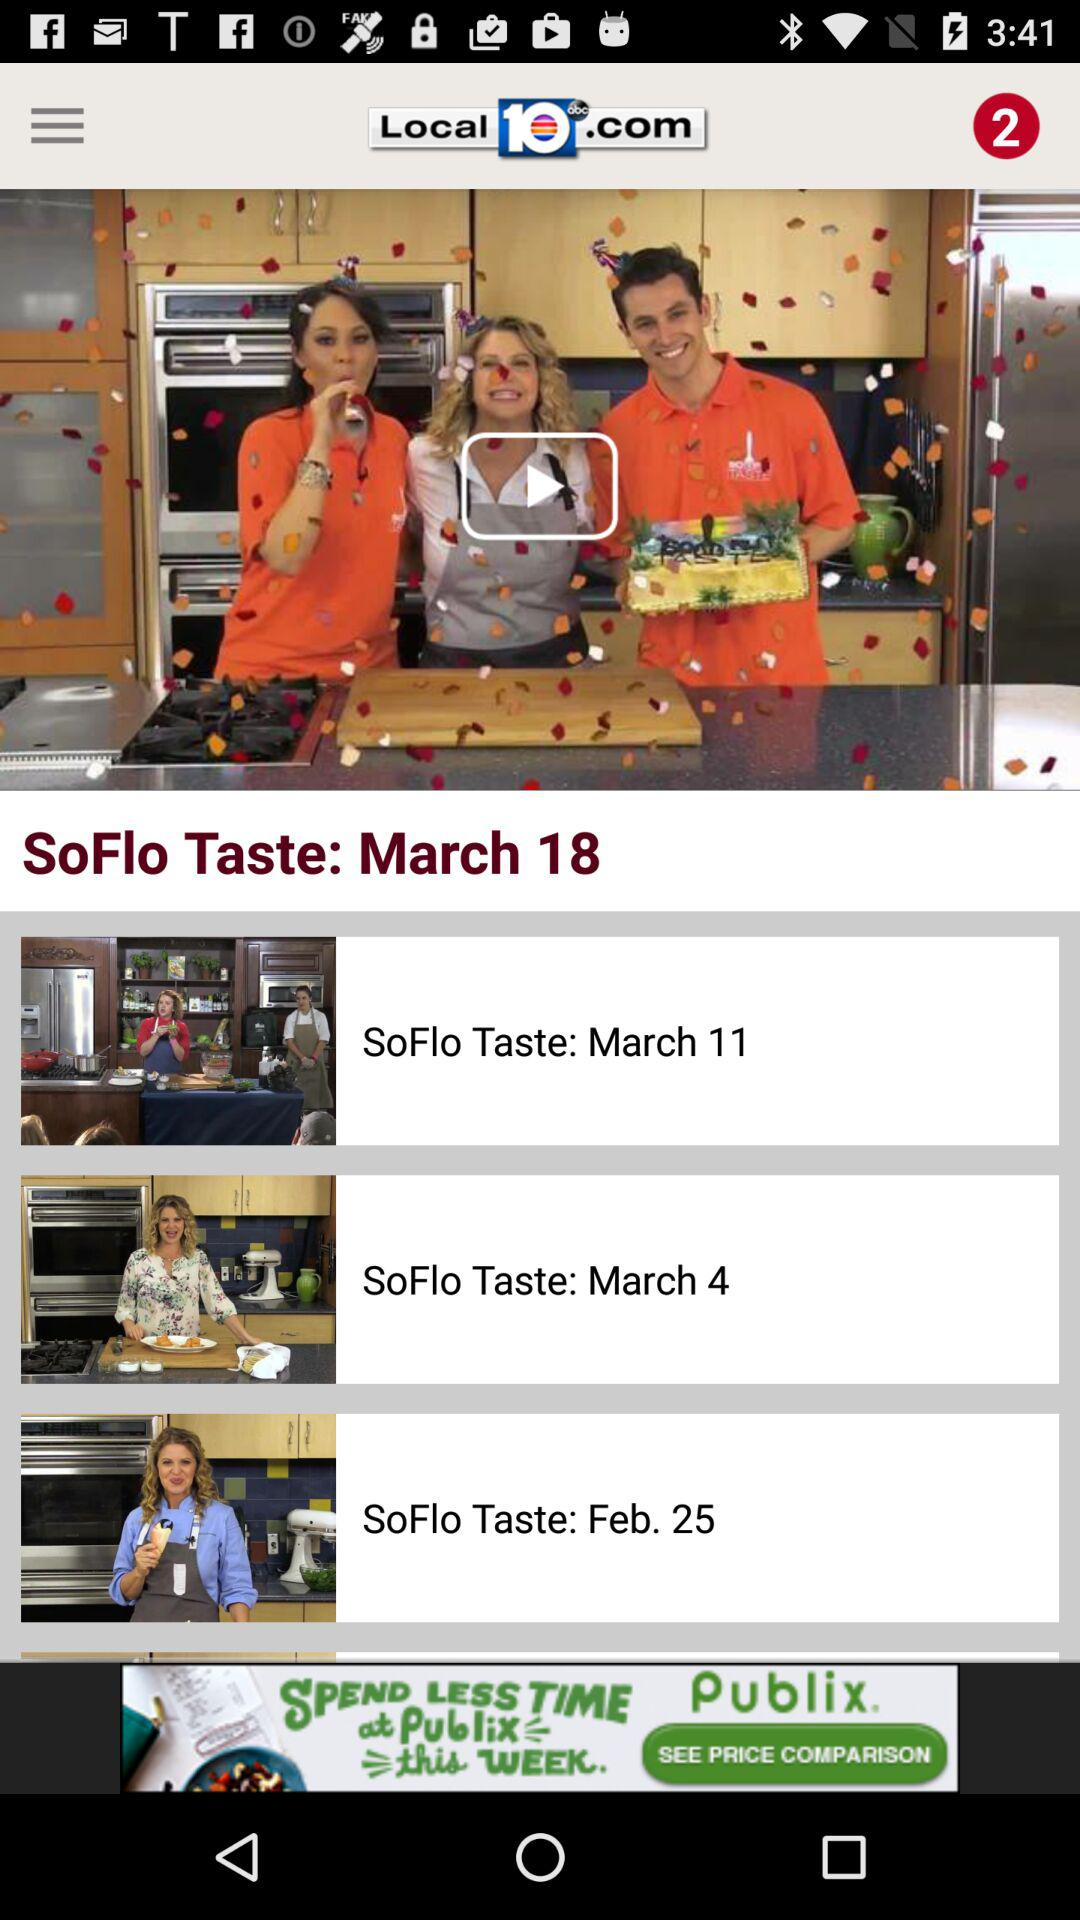What is the date of the current "SoFlo Taste" video in the player? The date of the current "SoFlo Taste" video in the player is March 18. 